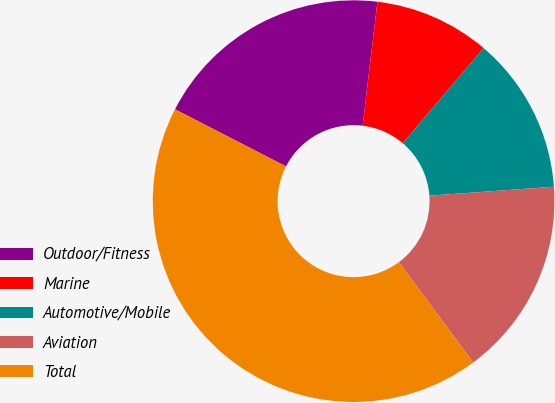Convert chart. <chart><loc_0><loc_0><loc_500><loc_500><pie_chart><fcel>Outdoor/Fitness<fcel>Marine<fcel>Automotive/Mobile<fcel>Aviation<fcel>Total<nl><fcel>19.33%<fcel>9.31%<fcel>12.65%<fcel>15.99%<fcel>42.71%<nl></chart> 